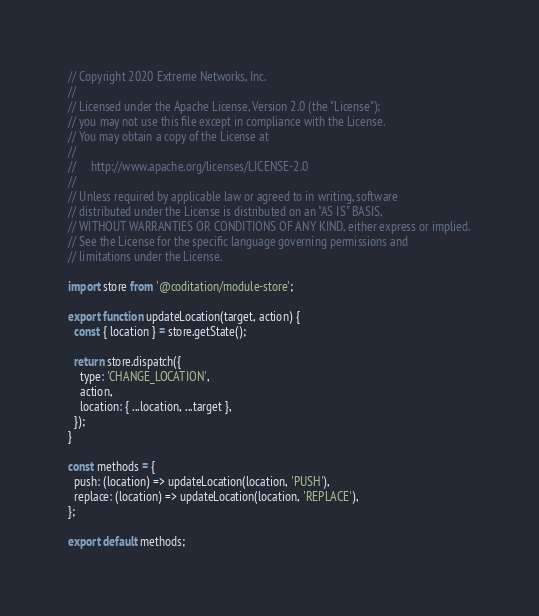<code> <loc_0><loc_0><loc_500><loc_500><_JavaScript_>// Copyright 2020 Extreme Networks, Inc.
//
// Licensed under the Apache License, Version 2.0 (the "License");
// you may not use this file except in compliance with the License.
// You may obtain a copy of the License at
//
//     http://www.apache.org/licenses/LICENSE-2.0
//
// Unless required by applicable law or agreed to in writing, software
// distributed under the License is distributed on an "AS IS" BASIS,
// WITHOUT WARRANTIES OR CONDITIONS OF ANY KIND, either express or implied.
// See the License for the specific language governing permissions and
// limitations under the License.

import store from '@coditation/module-store';

export function updateLocation(target, action) {
  const { location } = store.getState();

  return store.dispatch({
    type: 'CHANGE_LOCATION',
    action,
    location: { ...location, ...target },
  });
}

const methods = {
  push: (location) => updateLocation(location, 'PUSH'),
  replace: (location) => updateLocation(location, 'REPLACE'),
};

export default methods;
</code> 